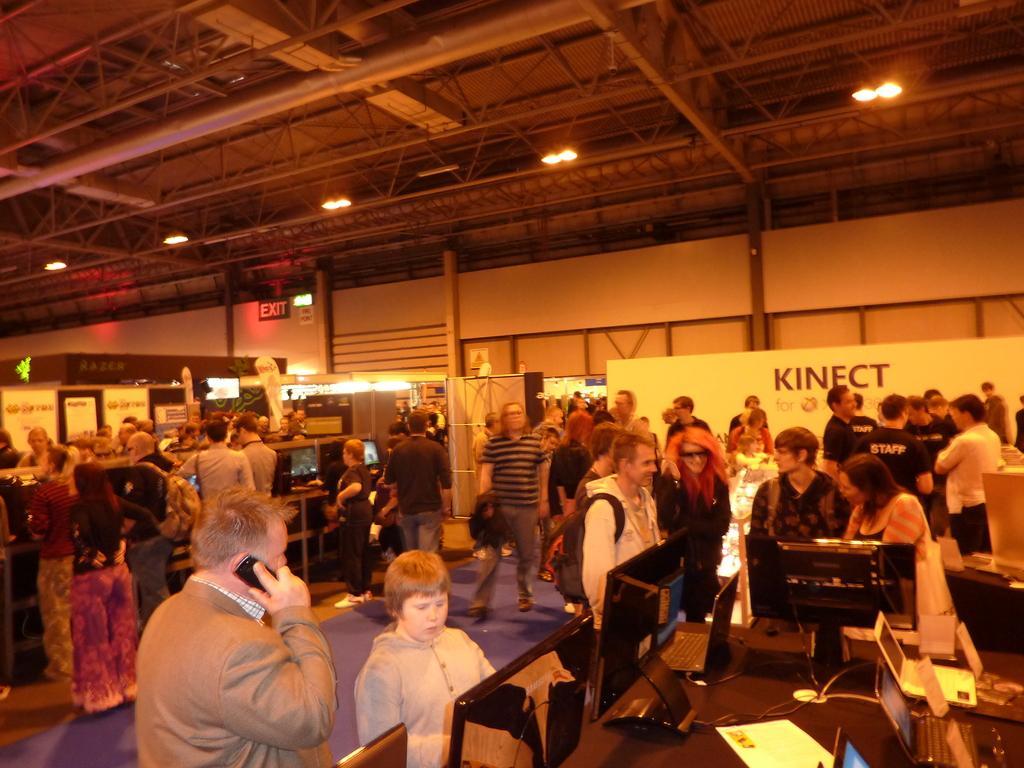In one or two sentences, can you explain what this image depicts? In this picture I can see many people who are standing near to the tables. On the table I can see many laptops, papers, cables, mouse, keyboard and other objects. At the top I can see the lights. 